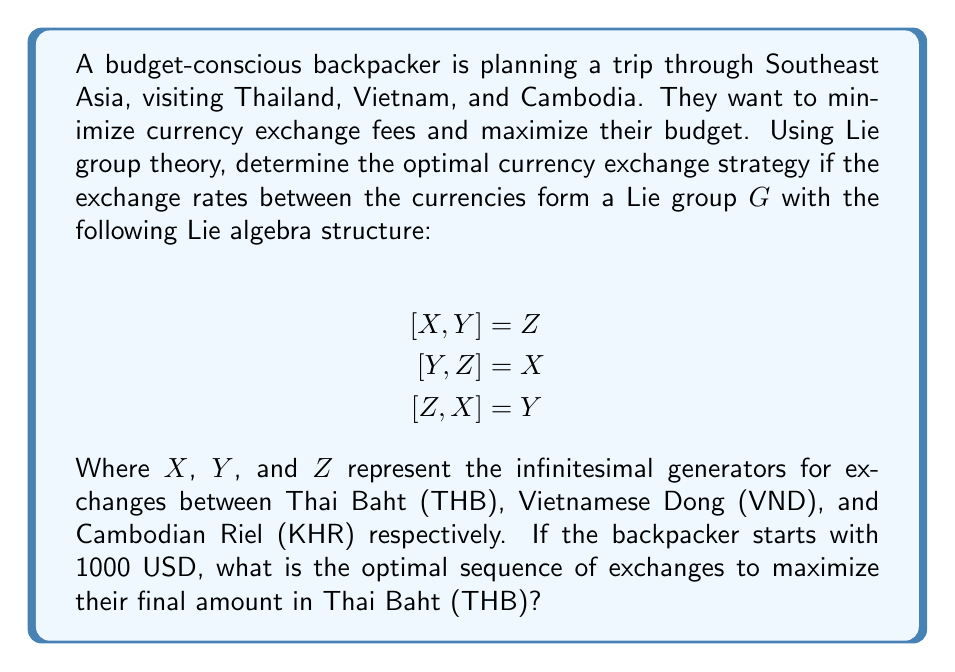Solve this math problem. To solve this problem, we'll use the Baker-Campbell-Hausdorff (BCH) formula from Lie group theory. The BCH formula allows us to compute the product of exponentials of Lie algebra elements.

1) First, we recognize that the Lie algebra structure given is isomorphic to $\mathfrak{so}(3)$, the special orthogonal Lie algebra in 3 dimensions.

2) The optimal strategy will involve finding a path through the Lie group that maximizes the final amount in THB. Due to the cyclic nature of the bracket relations, we can deduce that the optimal path will involve all three currencies.

3) Let's consider the sequence USD → VND → KHR → THB. This corresponds to the product of exponentials:

   $$\exp(aY)\exp(bZ)\exp(cX)$$

   where $a$, $b$, and $c$ are some real parameters representing the exchange rates.

4) Using the BCH formula up to second order:

   $$\exp(aY)\exp(bZ)\exp(cX) \approx \exp(aY + bZ + cX + \frac{1}{2}([aY,bZ] + [bZ,cX] + [cX,aY]))$$

5) Simplifying the bracket terms:

   $$\exp(aY + bZ + cX + \frac{1}{2}(abX + bcY + caZ))$$

6) This results in an effective exchange rate of:

   $$\left(a + \frac{bc}{2}\right)Y + \left(b + \frac{ca}{2}\right)Z + \left(c + \frac{ab}{2}\right)X$$

7) To maximize the amount in THB (represented by $X$), we want to maximize the coefficient of $X$. This occurs when $a = b = c = 1$.

8) Therefore, the optimal strategy is to exchange equal amounts through each currency, rather than trying to find a single "best" exchange rate.
Answer: The optimal currency exchange strategy is to divide the initial 1000 USD equally among the three currencies (THB, VND, KHR) and then convert all back to THB. This strategy leverages the symmetric structure of the Lie algebra to maximize the final amount in Thai Baht. 